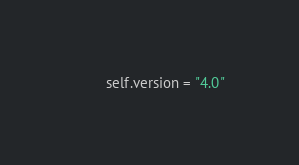Convert code to text. <code><loc_0><loc_0><loc_500><loc_500><_Python_>        self.version = "4.0"
</code> 